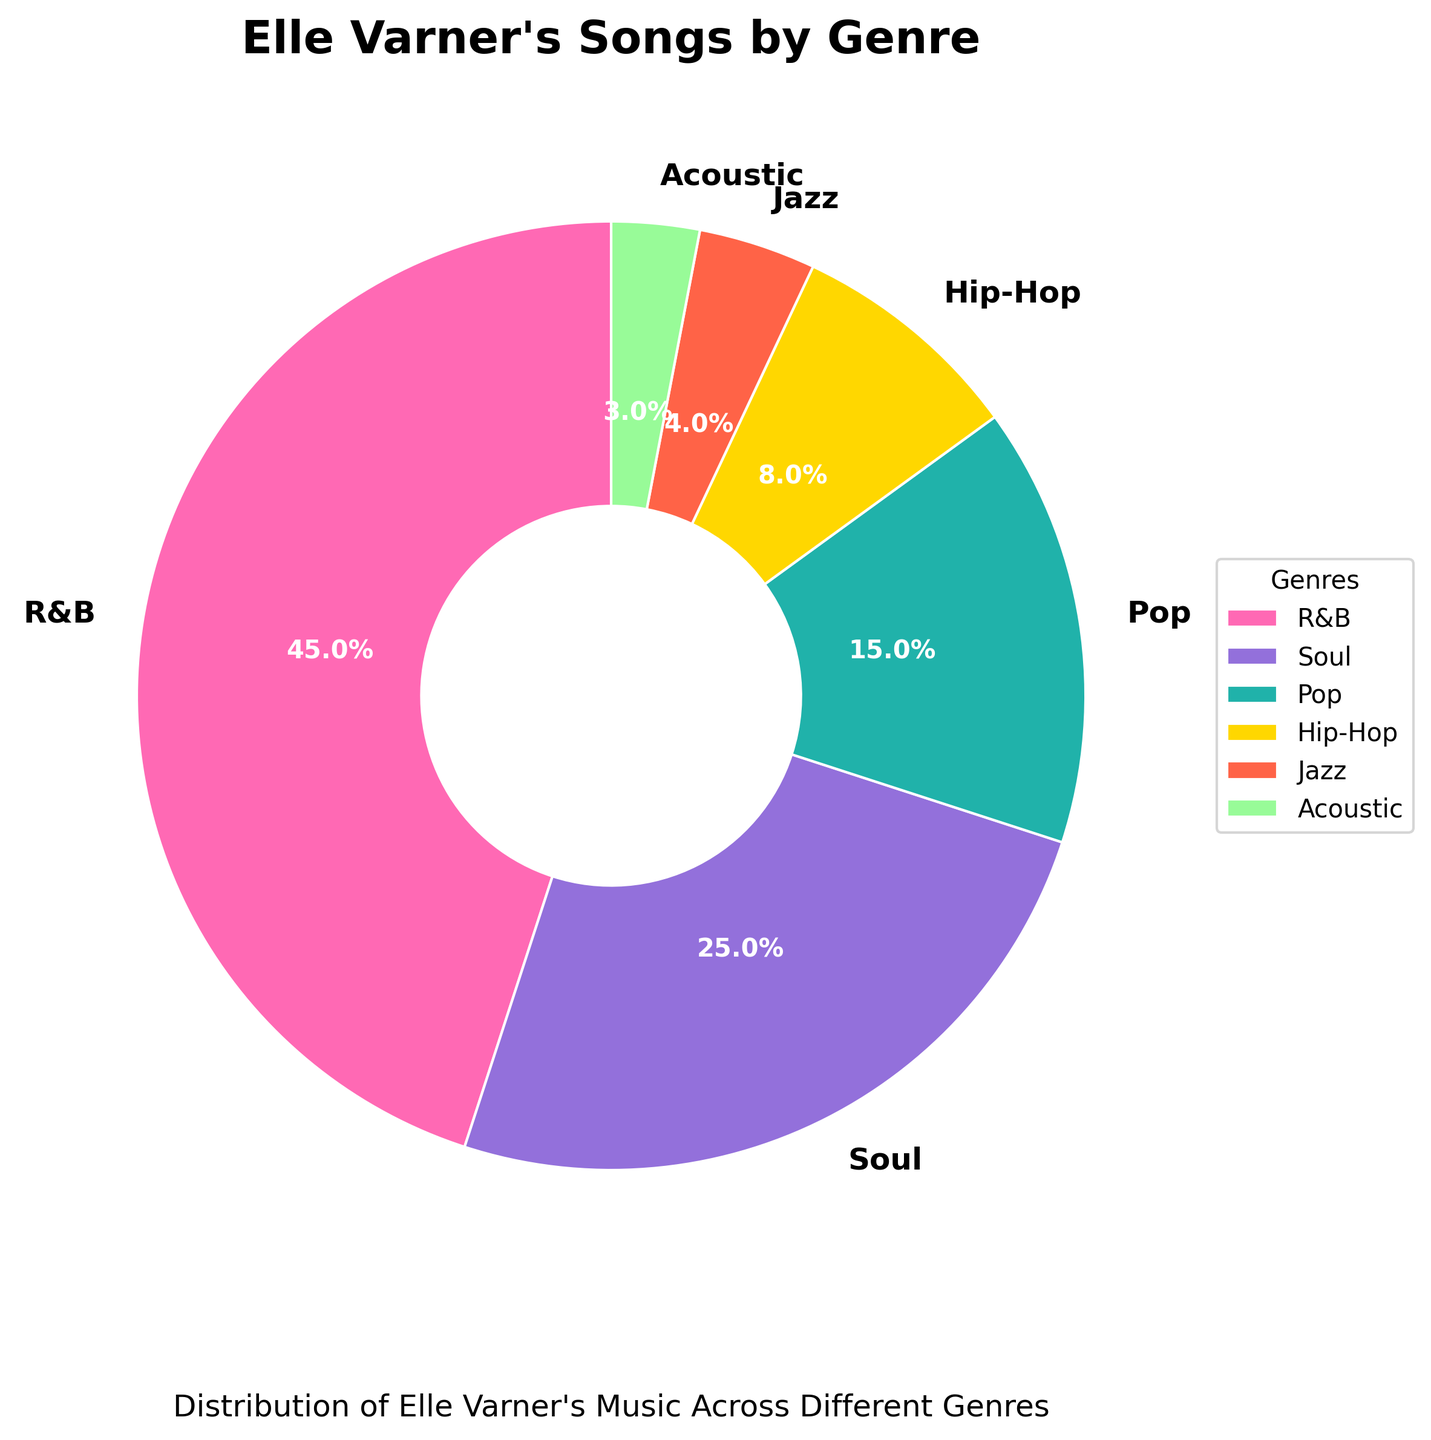What's the most common genre in Elle Varner's songs, according to the chart? The pie chart shows R&B taking up the largest portion.
Answer: R&B Which genre has the smallest percentage in the chart? The pie chart shows Acoustic having the smallest segment.
Answer: Acoustic What is the combined percentage of Soul and Jazz genres? Soul is 25% and Jazz is 4%, so their combined percentage is 25 + 4 = 29%.
Answer: 29% Which genre has a larger percentage, Pop or Hip-Hop? The pie chart shows Pop with 15% and Hip-Hop with 8%, so Pop has a larger percentage.
Answer: Pop By how much does the percentage of R&B exceed the percentage of Pop? R&B is 45% and Pop is 15%. The difference is 45 - 15 = 30%.
Answer: 30% What percentage of Elle Varner's songs fall under genres other than R&B? Total percentage excluding R&B: 100 - 45 = 55%.
Answer: 55% Which genres together make up more than half of Elle Varner's songs? The pie chart shows that R&B (45%) and Soul (25%) together account for more than 50%.
Answer: R&B and Soul How much larger is the percentage of Soul songs compared to Jazz songs? Soul is 25% and Jazz is 4%. The difference is 25 - 4 = 21%.
Answer: 21% What is the total percentage of the genres that each have a percentage less than 10%? The genres with percentages less than 10% are Hip-Hop (8%), Jazz (4%), and Acoustic (3%). Their total is 8 + 4 + 3 = 15%.
Answer: 15% What is the percentage difference between the highest and the lowest represented genres? The highest (R&B) is 45% and the lowest (Acoustic) is 3%. The difference is 45 - 3 = 42%.
Answer: 42% 